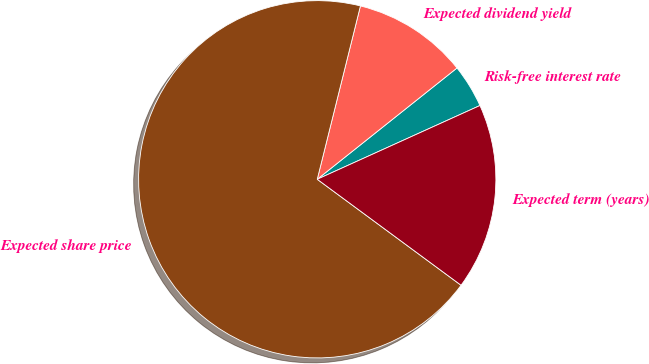Convert chart. <chart><loc_0><loc_0><loc_500><loc_500><pie_chart><fcel>Risk-free interest rate<fcel>Expected dividend yield<fcel>Expected share price<fcel>Expected term (years)<nl><fcel>3.93%<fcel>10.41%<fcel>68.78%<fcel>16.88%<nl></chart> 